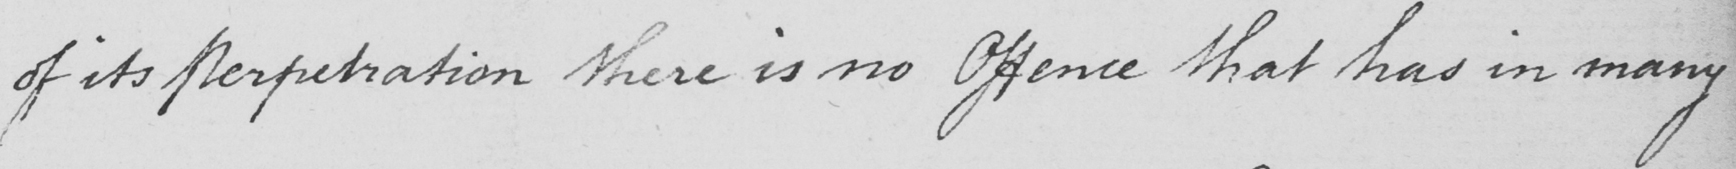Please transcribe the handwritten text in this image. of its Perpetration there is no Offence that has in many 